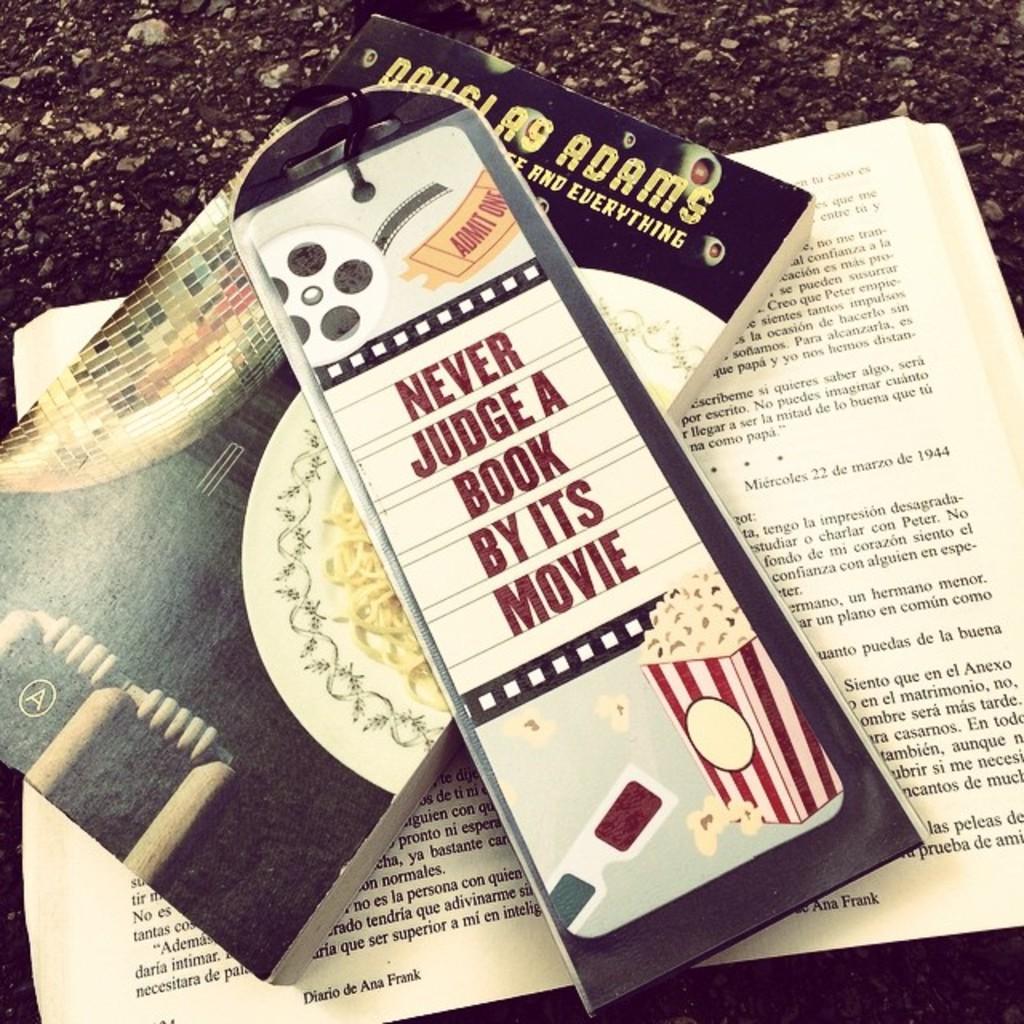What does the book say?
Keep it short and to the point. Never judge a book by its movie. What is the title of the opened book?
Make the answer very short. Diario de ana frank. 